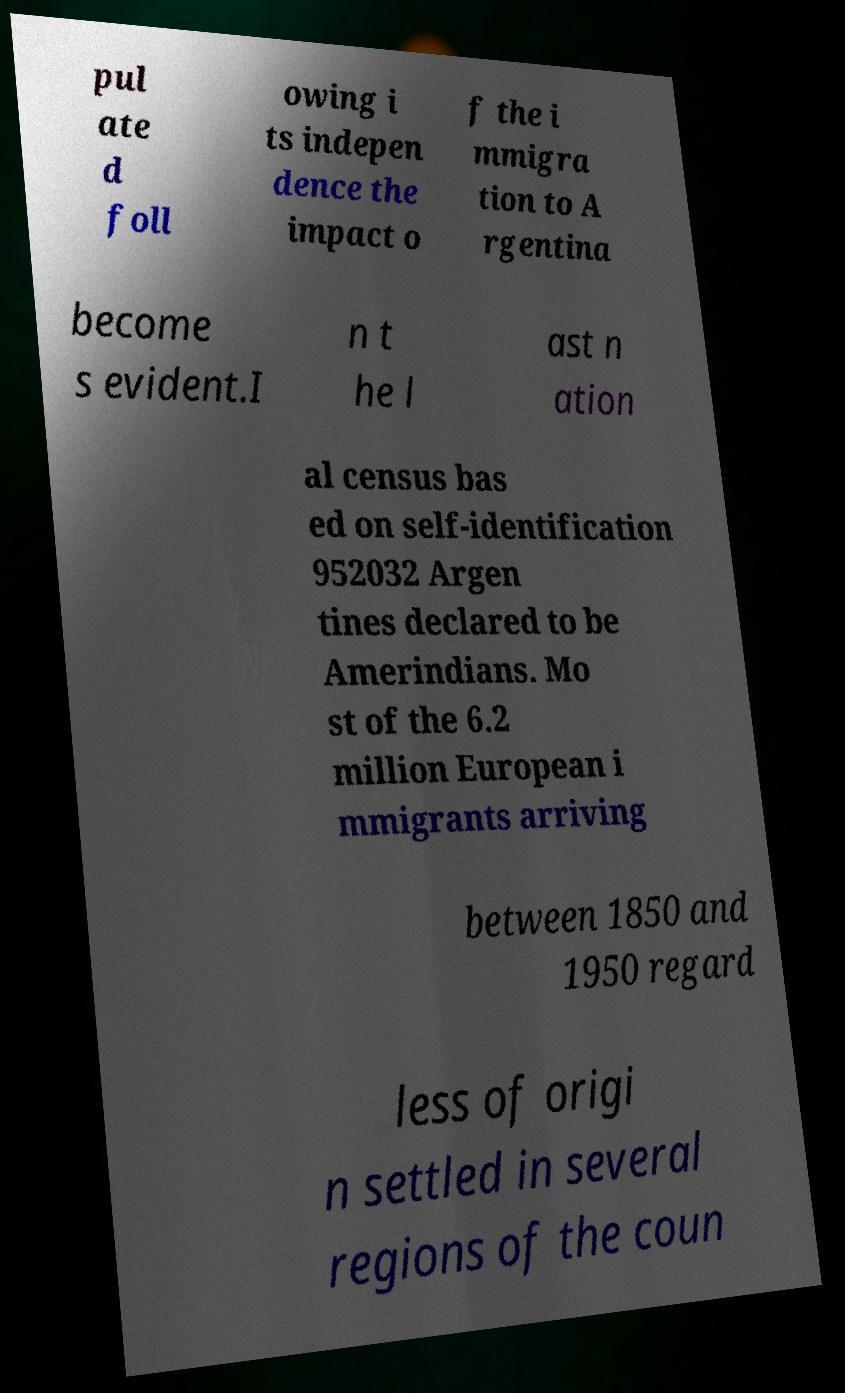There's text embedded in this image that I need extracted. Can you transcribe it verbatim? pul ate d foll owing i ts indepen dence the impact o f the i mmigra tion to A rgentina become s evident.I n t he l ast n ation al census bas ed on self-identification 952032 Argen tines declared to be Amerindians. Mo st of the 6.2 million European i mmigrants arriving between 1850 and 1950 regard less of origi n settled in several regions of the coun 